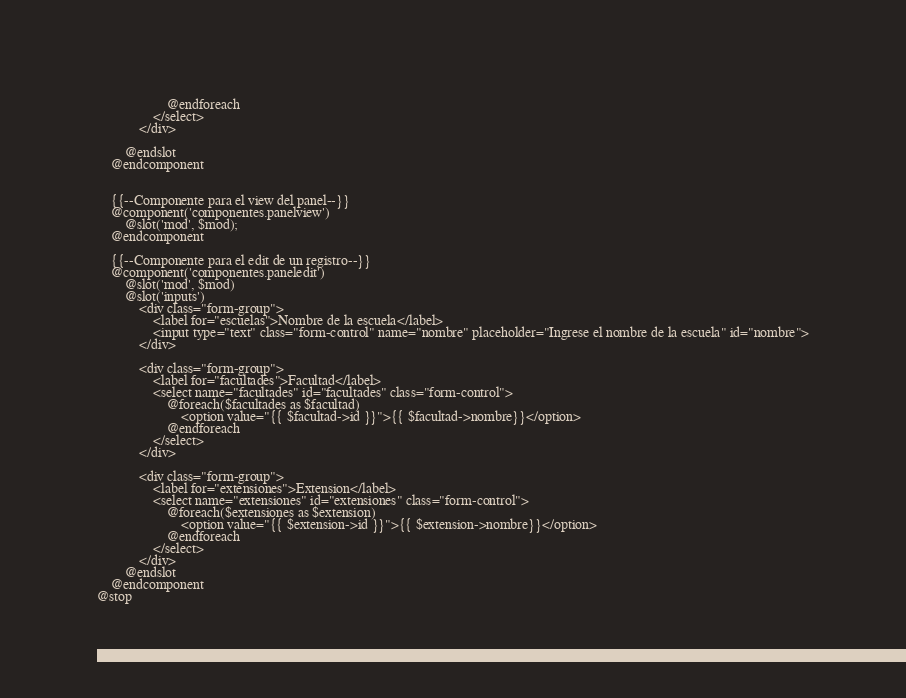Convert code to text. <code><loc_0><loc_0><loc_500><loc_500><_PHP_>                    @endforeach
                </select>
            </div>

        @endslot
    @endcomponent


    {{--Componente para el view del panel--}}
    @component('componentes.panelview')
        @slot('mod', $mod);
    @endcomponent

    {{--Componente para el edit de un registro--}}
    @component('componentes.paneledit')
        @slot('mod', $mod)
        @slot('inputs')
            <div class="form-group">
                <label for="escuelas">Nombre de la escuela</label>
                <input type="text" class="form-control" name="nombre" placeholder="Ingrese el nombre de la escuela" id="nombre">
            </div>

            <div class="form-group">
                <label for="facultades">Facultad</label>
                <select name="facultades" id="facultades" class="form-control">
                    @foreach($facultades as $facultad)
                        <option value="{{ $facultad->id }}">{{ $facultad->nombre}}</option>
                    @endforeach
                </select>
            </div>

            <div class="form-group">
                <label for="extensiones">Extension</label>
                <select name="extensiones" id="extensiones" class="form-control">
                    @foreach($extensiones as $extension)
                        <option value="{{ $extension->id }}">{{ $extension->nombre}}</option>
                    @endforeach
                </select>
            </div>
        @endslot
    @endcomponent
@stop</code> 